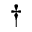Convert formula to latex. <formula><loc_0><loc_0><loc_500><loc_500>^ { \dagger }</formula> 